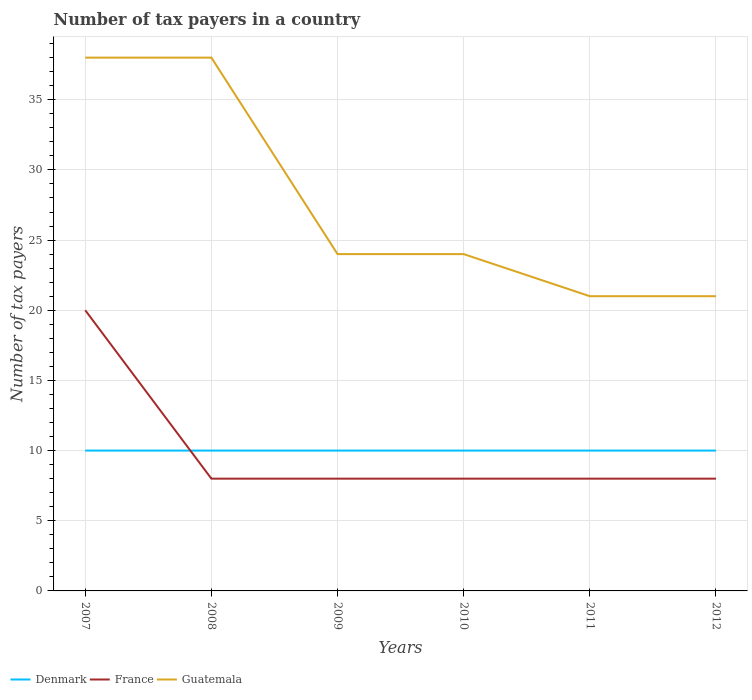Does the line corresponding to Guatemala intersect with the line corresponding to Denmark?
Your answer should be very brief. No. Is the number of lines equal to the number of legend labels?
Give a very brief answer. Yes. Across all years, what is the maximum number of tax payers in in France?
Offer a very short reply. 8. What is the difference between the highest and the second highest number of tax payers in in Denmark?
Offer a very short reply. 0. Are the values on the major ticks of Y-axis written in scientific E-notation?
Offer a terse response. No. Does the graph contain any zero values?
Your response must be concise. No. Does the graph contain grids?
Offer a terse response. Yes. How are the legend labels stacked?
Your response must be concise. Horizontal. What is the title of the graph?
Offer a terse response. Number of tax payers in a country. What is the label or title of the Y-axis?
Make the answer very short. Number of tax payers. What is the Number of tax payers of France in 2007?
Your answer should be very brief. 20. What is the Number of tax payers of France in 2010?
Ensure brevity in your answer.  8. What is the Number of tax payers in Guatemala in 2010?
Provide a succinct answer. 24. What is the Number of tax payers of Denmark in 2011?
Your response must be concise. 10. What is the Number of tax payers of France in 2011?
Provide a succinct answer. 8. What is the Number of tax payers of Guatemala in 2011?
Offer a very short reply. 21. What is the Number of tax payers in France in 2012?
Offer a very short reply. 8. Across all years, what is the minimum Number of tax payers of France?
Make the answer very short. 8. What is the total Number of tax payers of France in the graph?
Keep it short and to the point. 60. What is the total Number of tax payers in Guatemala in the graph?
Your answer should be compact. 166. What is the difference between the Number of tax payers in France in 2007 and that in 2008?
Offer a terse response. 12. What is the difference between the Number of tax payers in Denmark in 2007 and that in 2009?
Your answer should be very brief. 0. What is the difference between the Number of tax payers of Guatemala in 2007 and that in 2009?
Your answer should be compact. 14. What is the difference between the Number of tax payers in France in 2007 and that in 2010?
Your response must be concise. 12. What is the difference between the Number of tax payers of France in 2007 and that in 2011?
Make the answer very short. 12. What is the difference between the Number of tax payers of Guatemala in 2007 and that in 2011?
Offer a very short reply. 17. What is the difference between the Number of tax payers in France in 2007 and that in 2012?
Ensure brevity in your answer.  12. What is the difference between the Number of tax payers in Guatemala in 2007 and that in 2012?
Offer a very short reply. 17. What is the difference between the Number of tax payers in Guatemala in 2008 and that in 2010?
Provide a succinct answer. 14. What is the difference between the Number of tax payers of Denmark in 2008 and that in 2012?
Your answer should be very brief. 0. What is the difference between the Number of tax payers in France in 2008 and that in 2012?
Give a very brief answer. 0. What is the difference between the Number of tax payers of Guatemala in 2008 and that in 2012?
Make the answer very short. 17. What is the difference between the Number of tax payers in Guatemala in 2009 and that in 2010?
Ensure brevity in your answer.  0. What is the difference between the Number of tax payers in France in 2009 and that in 2011?
Provide a short and direct response. 0. What is the difference between the Number of tax payers in Guatemala in 2009 and that in 2011?
Ensure brevity in your answer.  3. What is the difference between the Number of tax payers in France in 2009 and that in 2012?
Offer a terse response. 0. What is the difference between the Number of tax payers of Guatemala in 2009 and that in 2012?
Give a very brief answer. 3. What is the difference between the Number of tax payers in Denmark in 2010 and that in 2011?
Keep it short and to the point. 0. What is the difference between the Number of tax payers of France in 2010 and that in 2011?
Your answer should be very brief. 0. What is the difference between the Number of tax payers of Guatemala in 2010 and that in 2011?
Provide a short and direct response. 3. What is the difference between the Number of tax payers in France in 2010 and that in 2012?
Ensure brevity in your answer.  0. What is the difference between the Number of tax payers in Guatemala in 2010 and that in 2012?
Provide a short and direct response. 3. What is the difference between the Number of tax payers in France in 2011 and that in 2012?
Offer a very short reply. 0. What is the difference between the Number of tax payers of Denmark in 2007 and the Number of tax payers of France in 2008?
Provide a short and direct response. 2. What is the difference between the Number of tax payers in Denmark in 2007 and the Number of tax payers in Guatemala in 2008?
Your answer should be very brief. -28. What is the difference between the Number of tax payers of France in 2007 and the Number of tax payers of Guatemala in 2008?
Give a very brief answer. -18. What is the difference between the Number of tax payers of France in 2007 and the Number of tax payers of Guatemala in 2010?
Make the answer very short. -4. What is the difference between the Number of tax payers of Denmark in 2007 and the Number of tax payers of France in 2011?
Ensure brevity in your answer.  2. What is the difference between the Number of tax payers of Denmark in 2007 and the Number of tax payers of Guatemala in 2011?
Your answer should be compact. -11. What is the difference between the Number of tax payers of Denmark in 2007 and the Number of tax payers of France in 2012?
Offer a very short reply. 2. What is the difference between the Number of tax payers in Denmark in 2008 and the Number of tax payers in Guatemala in 2010?
Your answer should be compact. -14. What is the difference between the Number of tax payers in France in 2008 and the Number of tax payers in Guatemala in 2010?
Provide a short and direct response. -16. What is the difference between the Number of tax payers of France in 2008 and the Number of tax payers of Guatemala in 2011?
Your answer should be compact. -13. What is the difference between the Number of tax payers in Denmark in 2008 and the Number of tax payers in France in 2012?
Your response must be concise. 2. What is the difference between the Number of tax payers of Denmark in 2008 and the Number of tax payers of Guatemala in 2012?
Offer a terse response. -11. What is the difference between the Number of tax payers in Denmark in 2009 and the Number of tax payers in France in 2010?
Offer a very short reply. 2. What is the difference between the Number of tax payers in Denmark in 2009 and the Number of tax payers in France in 2011?
Give a very brief answer. 2. What is the difference between the Number of tax payers of Denmark in 2009 and the Number of tax payers of Guatemala in 2011?
Offer a very short reply. -11. What is the difference between the Number of tax payers of Denmark in 2009 and the Number of tax payers of France in 2012?
Give a very brief answer. 2. What is the difference between the Number of tax payers of Denmark in 2009 and the Number of tax payers of Guatemala in 2012?
Give a very brief answer. -11. What is the difference between the Number of tax payers in Denmark in 2010 and the Number of tax payers in France in 2011?
Keep it short and to the point. 2. What is the difference between the Number of tax payers in France in 2010 and the Number of tax payers in Guatemala in 2011?
Your response must be concise. -13. What is the difference between the Number of tax payers of Denmark in 2011 and the Number of tax payers of France in 2012?
Make the answer very short. 2. What is the difference between the Number of tax payers in France in 2011 and the Number of tax payers in Guatemala in 2012?
Ensure brevity in your answer.  -13. What is the average Number of tax payers in Guatemala per year?
Offer a terse response. 27.67. In the year 2007, what is the difference between the Number of tax payers in Denmark and Number of tax payers in France?
Your answer should be very brief. -10. In the year 2007, what is the difference between the Number of tax payers of Denmark and Number of tax payers of Guatemala?
Keep it short and to the point. -28. In the year 2007, what is the difference between the Number of tax payers of France and Number of tax payers of Guatemala?
Make the answer very short. -18. In the year 2008, what is the difference between the Number of tax payers of France and Number of tax payers of Guatemala?
Ensure brevity in your answer.  -30. In the year 2009, what is the difference between the Number of tax payers in Denmark and Number of tax payers in France?
Provide a short and direct response. 2. In the year 2009, what is the difference between the Number of tax payers in France and Number of tax payers in Guatemala?
Your answer should be compact. -16. In the year 2010, what is the difference between the Number of tax payers in Denmark and Number of tax payers in Guatemala?
Your response must be concise. -14. In the year 2011, what is the difference between the Number of tax payers of Denmark and Number of tax payers of France?
Provide a succinct answer. 2. In the year 2011, what is the difference between the Number of tax payers in France and Number of tax payers in Guatemala?
Your response must be concise. -13. What is the ratio of the Number of tax payers of Guatemala in 2007 to that in 2008?
Provide a succinct answer. 1. What is the ratio of the Number of tax payers in Guatemala in 2007 to that in 2009?
Provide a short and direct response. 1.58. What is the ratio of the Number of tax payers of Guatemala in 2007 to that in 2010?
Provide a short and direct response. 1.58. What is the ratio of the Number of tax payers of France in 2007 to that in 2011?
Offer a terse response. 2.5. What is the ratio of the Number of tax payers in Guatemala in 2007 to that in 2011?
Provide a succinct answer. 1.81. What is the ratio of the Number of tax payers of Denmark in 2007 to that in 2012?
Make the answer very short. 1. What is the ratio of the Number of tax payers of Guatemala in 2007 to that in 2012?
Give a very brief answer. 1.81. What is the ratio of the Number of tax payers in Denmark in 2008 to that in 2009?
Keep it short and to the point. 1. What is the ratio of the Number of tax payers in Guatemala in 2008 to that in 2009?
Offer a very short reply. 1.58. What is the ratio of the Number of tax payers of Denmark in 2008 to that in 2010?
Make the answer very short. 1. What is the ratio of the Number of tax payers in France in 2008 to that in 2010?
Your answer should be very brief. 1. What is the ratio of the Number of tax payers of Guatemala in 2008 to that in 2010?
Provide a short and direct response. 1.58. What is the ratio of the Number of tax payers in Denmark in 2008 to that in 2011?
Provide a succinct answer. 1. What is the ratio of the Number of tax payers in France in 2008 to that in 2011?
Give a very brief answer. 1. What is the ratio of the Number of tax payers of Guatemala in 2008 to that in 2011?
Offer a terse response. 1.81. What is the ratio of the Number of tax payers of Guatemala in 2008 to that in 2012?
Give a very brief answer. 1.81. What is the ratio of the Number of tax payers in Denmark in 2009 to that in 2010?
Give a very brief answer. 1. What is the ratio of the Number of tax payers in France in 2009 to that in 2010?
Make the answer very short. 1. What is the ratio of the Number of tax payers of Guatemala in 2009 to that in 2010?
Your answer should be very brief. 1. What is the ratio of the Number of tax payers in Denmark in 2009 to that in 2011?
Provide a succinct answer. 1. What is the ratio of the Number of tax payers of France in 2009 to that in 2011?
Your answer should be compact. 1. What is the ratio of the Number of tax payers of France in 2009 to that in 2012?
Provide a short and direct response. 1. What is the ratio of the Number of tax payers in Denmark in 2010 to that in 2011?
Your answer should be compact. 1. What is the ratio of the Number of tax payers of Denmark in 2010 to that in 2012?
Provide a short and direct response. 1. What is the ratio of the Number of tax payers of France in 2010 to that in 2012?
Your answer should be compact. 1. What is the ratio of the Number of tax payers in Guatemala in 2010 to that in 2012?
Keep it short and to the point. 1.14. What is the ratio of the Number of tax payers of Guatemala in 2011 to that in 2012?
Provide a short and direct response. 1. What is the difference between the highest and the lowest Number of tax payers in Guatemala?
Your answer should be very brief. 17. 